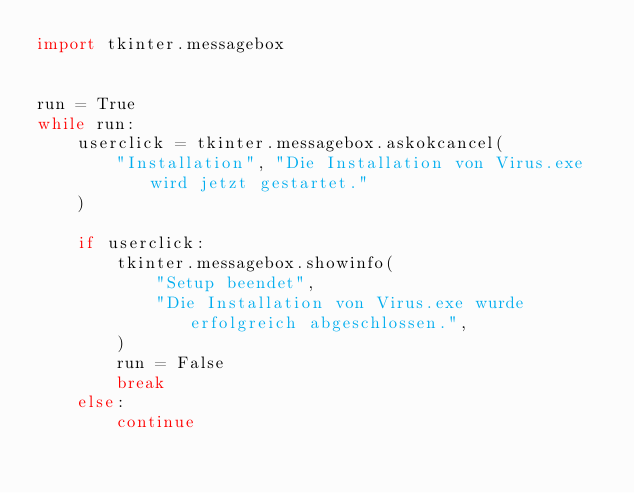Convert code to text. <code><loc_0><loc_0><loc_500><loc_500><_Python_>import tkinter.messagebox


run = True
while run:
    userclick = tkinter.messagebox.askokcancel(
        "Installation", "Die Installation von Virus.exe wird jetzt gestartet."
    )

    if userclick:
        tkinter.messagebox.showinfo(
            "Setup beendet",
            "Die Installation von Virus.exe wurde erfolgreich abgeschlossen.",
        )
        run = False
        break
    else:
        continue
</code> 